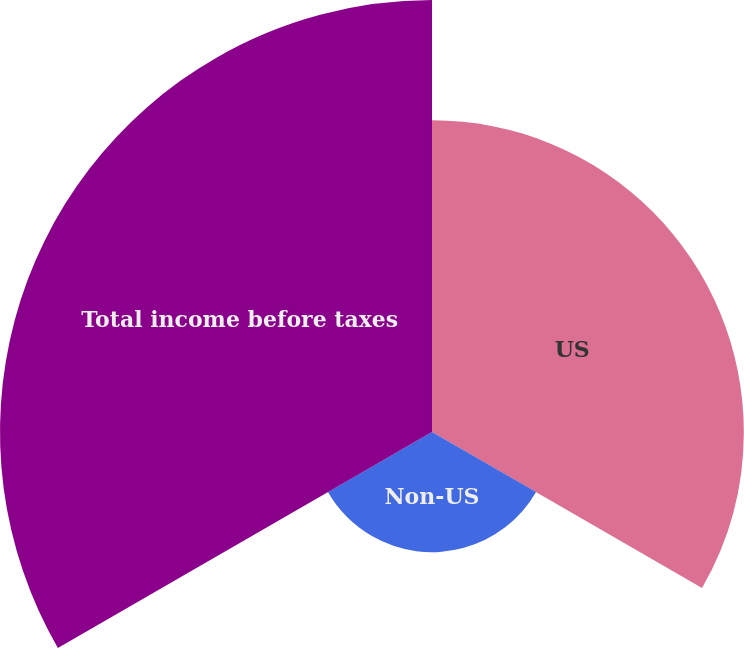Convert chart to OTSL. <chart><loc_0><loc_0><loc_500><loc_500><pie_chart><fcel>US<fcel>Non-US<fcel>Total income before taxes<nl><fcel>36.09%<fcel>13.91%<fcel>50.0%<nl></chart> 